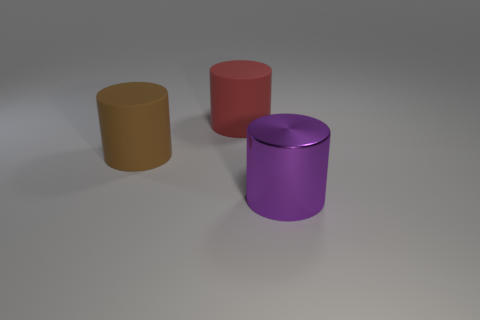Add 2 big brown metal things. How many objects exist? 5 Subtract all yellow objects. Subtract all large brown things. How many objects are left? 2 Add 3 large purple metallic cylinders. How many large purple metallic cylinders are left? 4 Add 2 brown matte cylinders. How many brown matte cylinders exist? 3 Subtract 0 yellow cubes. How many objects are left? 3 